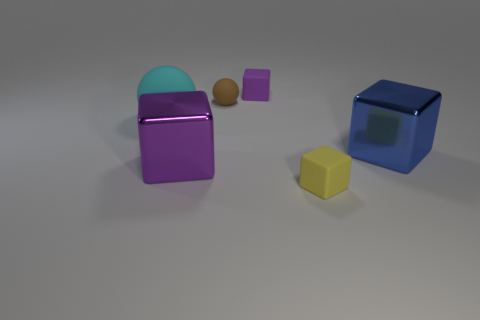Subtract all large blue shiny blocks. How many blocks are left? 3 Subtract all yellow blocks. How many blocks are left? 3 Add 3 large metal blocks. How many objects exist? 9 Subtract all purple spheres. How many purple blocks are left? 2 Subtract all balls. How many objects are left? 4 Add 2 purple shiny objects. How many purple shiny objects are left? 3 Add 1 large balls. How many large balls exist? 2 Subtract 0 red balls. How many objects are left? 6 Subtract all gray blocks. Subtract all brown cylinders. How many blocks are left? 4 Subtract all rubber cubes. Subtract all big blue metallic cubes. How many objects are left? 3 